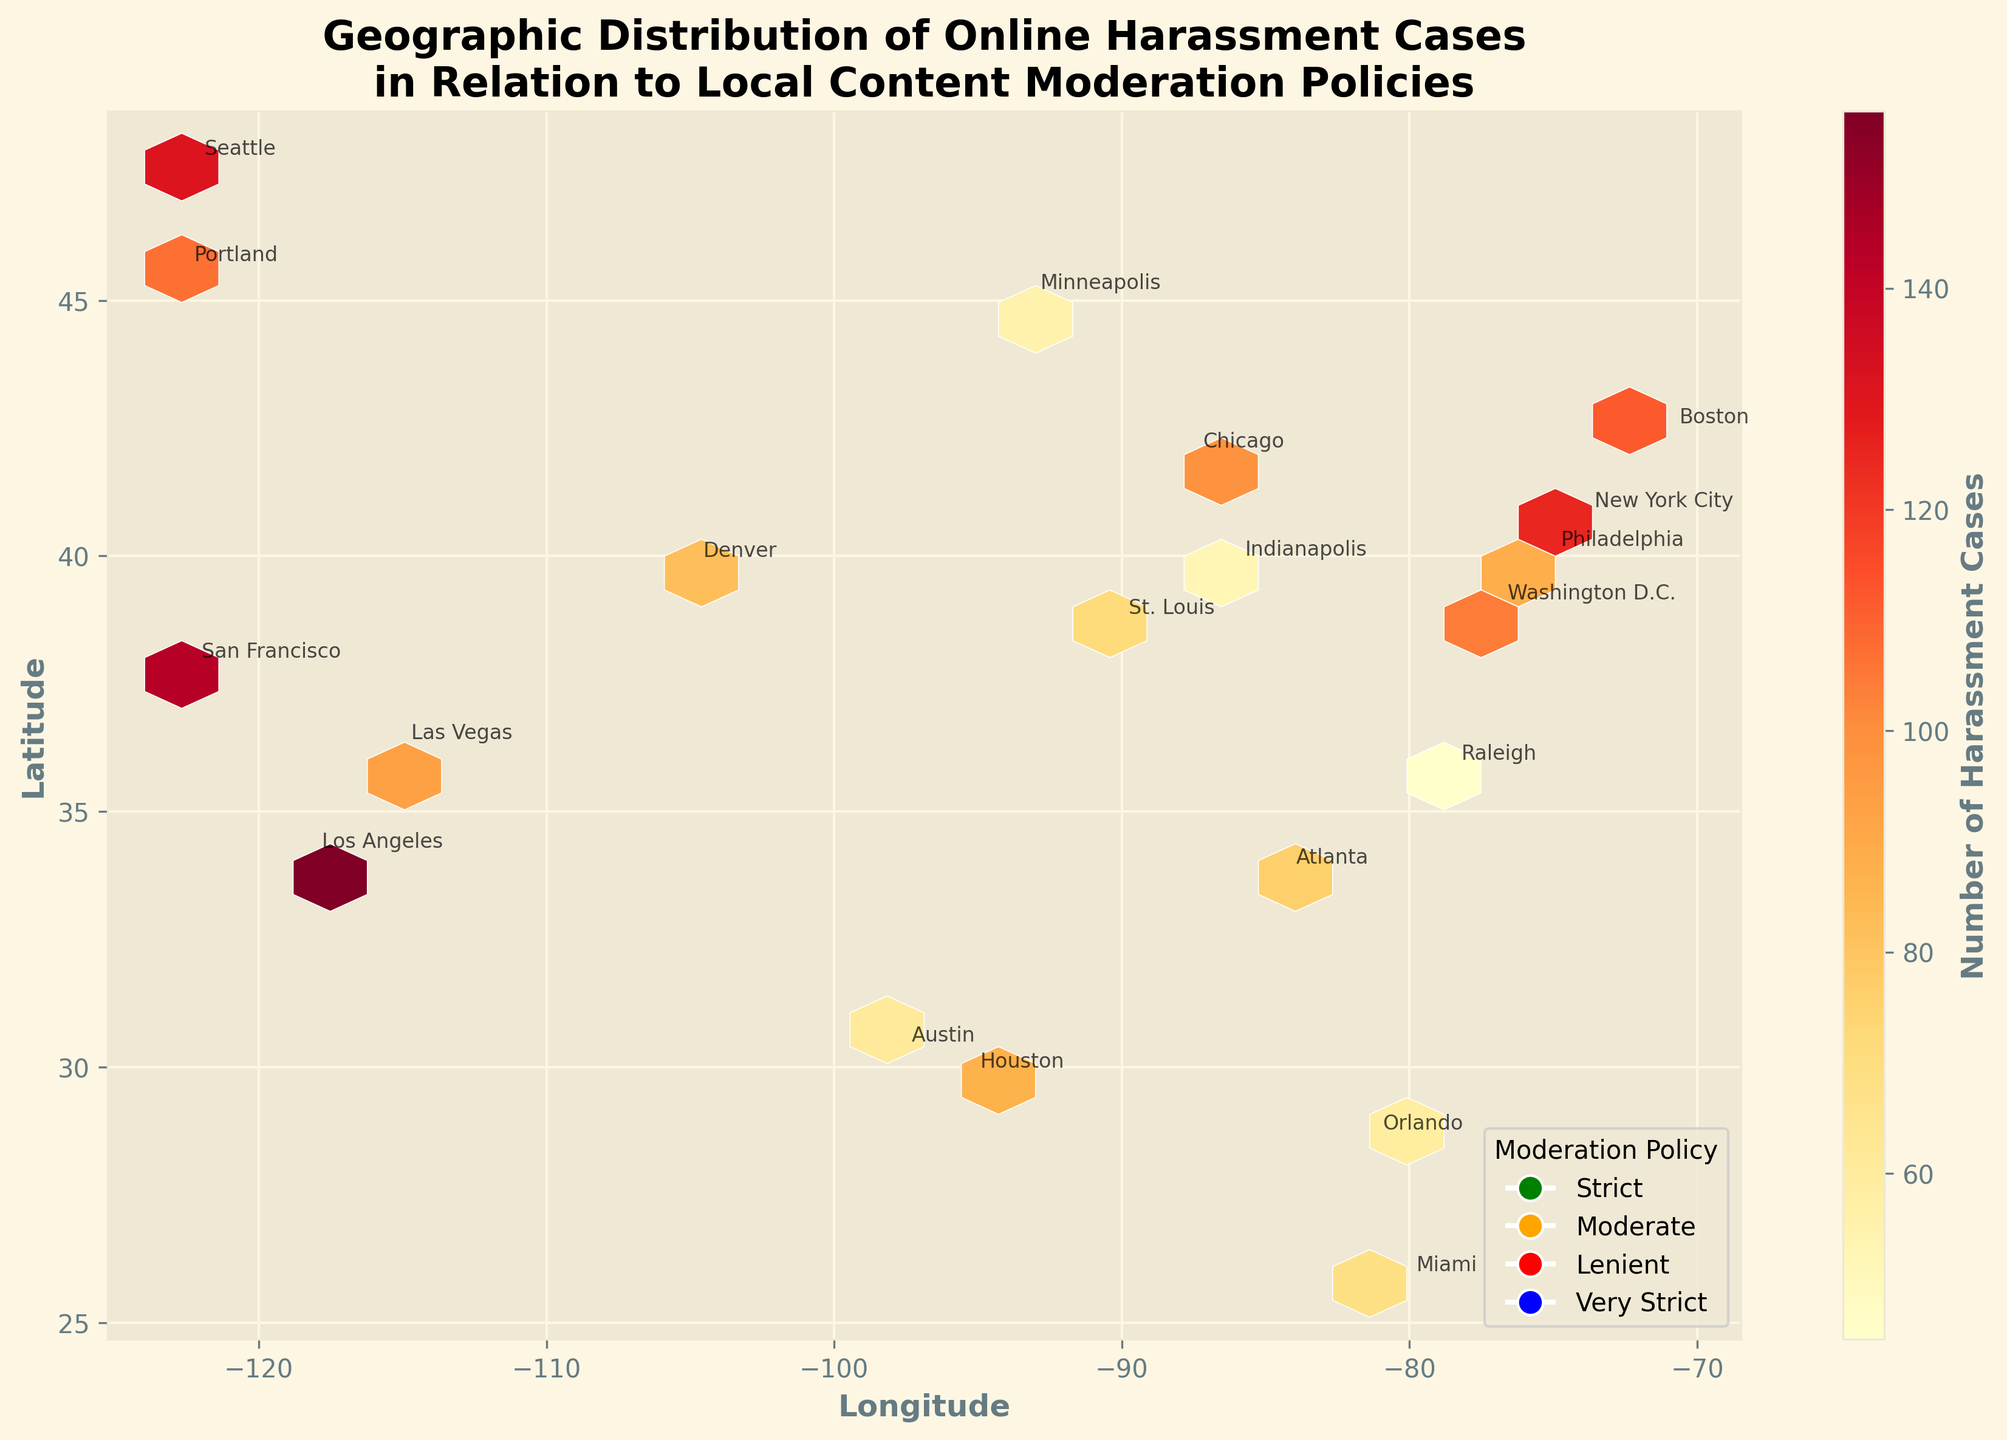What is the title of the plot? The title is located at the top of the figure and provides a general description of the data being presented. The full title reads: "Geographic Distribution of Online Harassment Cases in Relation to Local Content Moderation Policies."
Answer: Geographic Distribution of Online Harassment Cases in Relation to Local Content Moderation Policies How many levels of content moderation policies are illustrated in the legend? The legend at the bottom right of the plot shows different levels of content moderation policies, each with a corresponding color. There are four levels: "Strict," "Moderate," "Lenient," and "Very Strict."
Answer: 4 Which city has the highest number of online harassment cases? By observing the annotated city names and their corresponding bin colors. The city with the darkest hexbin shade indicating the highest number of cases is Los Angeles.
Answer: Los Angeles What color represents regions with a "Very Strict" content moderation policy, and which cities fall under this category? The legend denotes that regions with a "Very Strict" content moderation policy are represented by blue. By looking at the annotations, the cities are San Francisco and Seattle.
Answer: Blue, San Francisco and Seattle Which city with a "Moderate" content moderation policy has the lowest number of online harassment cases? From the legend, "Moderate" content moderation areas are marked with orange. Observing the hexbin colors and annotations, Minneapolis, with a count of 55, has the lowest cases among moderately regulated cities.
Answer: Minneapolis Compare New York City and Houston; which city has a stricter content moderation policy and more harassment cases? New York City has a "Strict" policy while Houston has a "Lenient" policy. New York City also has more harassment cases with 125 compared to Houston's 87.
Answer: New York City, Strict, 125 vs 87 Calculate the average number of harassment cases for cities with a "Strict" content moderation policy. The cities with "Strict" policies are New York City (125), Los Angeles (156), Boston (112), Washington D.C. (104), and Portland (107). Sum these counts: 125 + 156 + 112 + 104 + 107 = 604. Divide by 5 to get the average: 604 / 5 = 120.8
Answer: 120.8 Which region in the eastern United States has a "Lenient" moderation policy and what is the number of harassment cases there? By checking the annotations and colors in the eastern part of the figure, Miami has a "Lenient" policy and 68 harassment cases.
Answer: Miami, 68 Are there any cities without harassment cases? All annotated cities in the hexbin plot show some level of harassment cases as indicated by the bin colors and numbers.
Answer: No Is there a visible correlation between the stringency of content moderation policies and the number of online harassment cases? By comparing the hexbin colors and observing the legend, it can be noted that more stringent moderation like "Very Strict" seems correlated with higher harassment cases, particularly when comparing areas like San Francisco and Seattle versus lenient regions like Miami and Raleigh.
Answer: Yes 